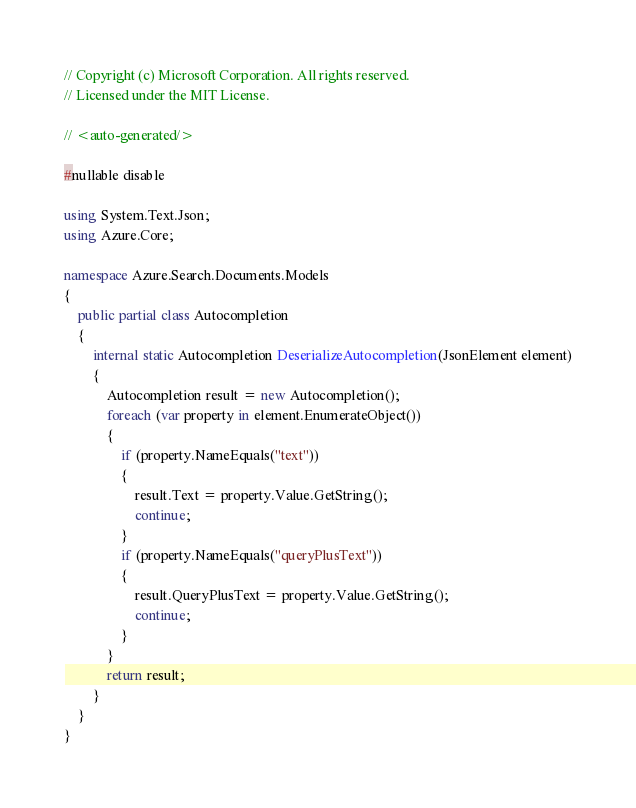Convert code to text. <code><loc_0><loc_0><loc_500><loc_500><_C#_>// Copyright (c) Microsoft Corporation. All rights reserved.
// Licensed under the MIT License.

// <auto-generated/>

#nullable disable

using System.Text.Json;
using Azure.Core;

namespace Azure.Search.Documents.Models
{
    public partial class Autocompletion
    {
        internal static Autocompletion DeserializeAutocompletion(JsonElement element)
        {
            Autocompletion result = new Autocompletion();
            foreach (var property in element.EnumerateObject())
            {
                if (property.NameEquals("text"))
                {
                    result.Text = property.Value.GetString();
                    continue;
                }
                if (property.NameEquals("queryPlusText"))
                {
                    result.QueryPlusText = property.Value.GetString();
                    continue;
                }
            }
            return result;
        }
    }
}
</code> 